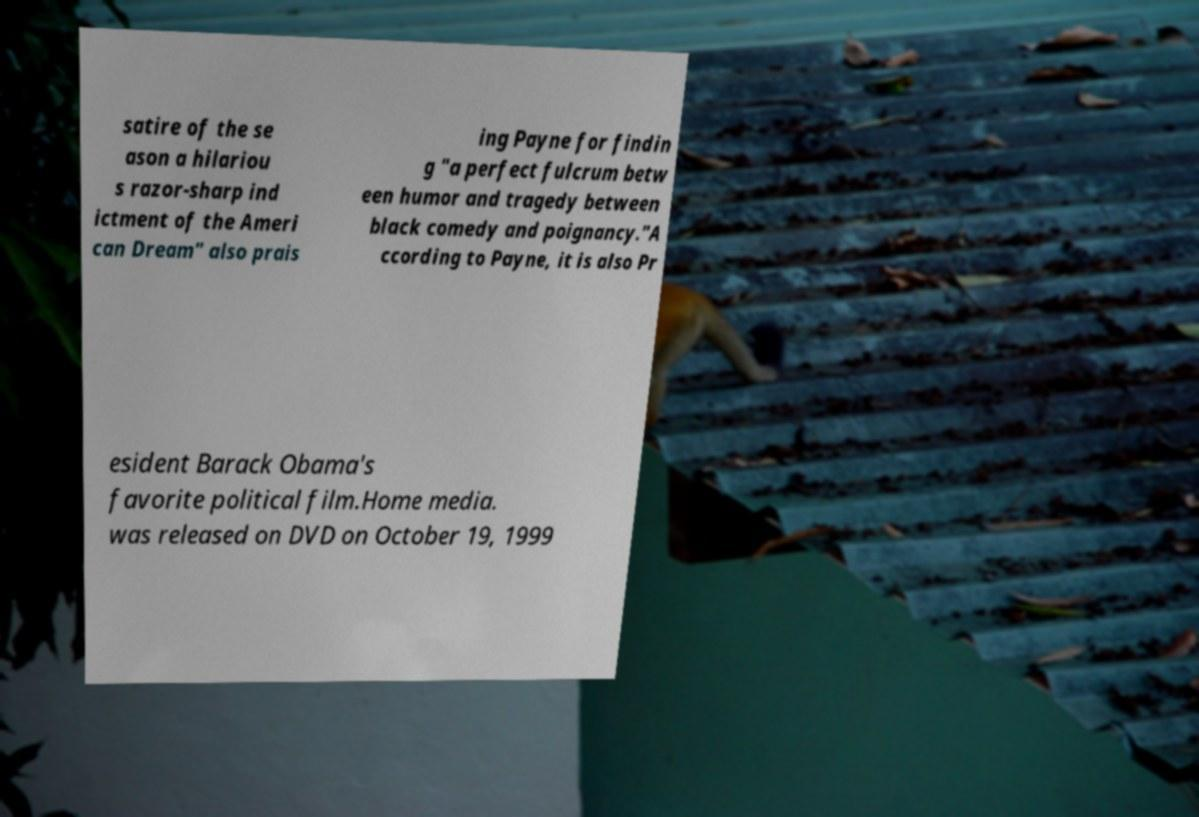Can you read and provide the text displayed in the image?This photo seems to have some interesting text. Can you extract and type it out for me? satire of the se ason a hilariou s razor-sharp ind ictment of the Ameri can Dream" also prais ing Payne for findin g "a perfect fulcrum betw een humor and tragedy between black comedy and poignancy."A ccording to Payne, it is also Pr esident Barack Obama's favorite political film.Home media. was released on DVD on October 19, 1999 